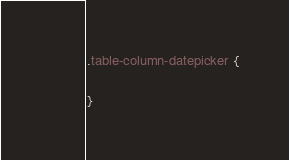<code> <loc_0><loc_0><loc_500><loc_500><_CSS_>.table-column-datepicker {

}
</code> 